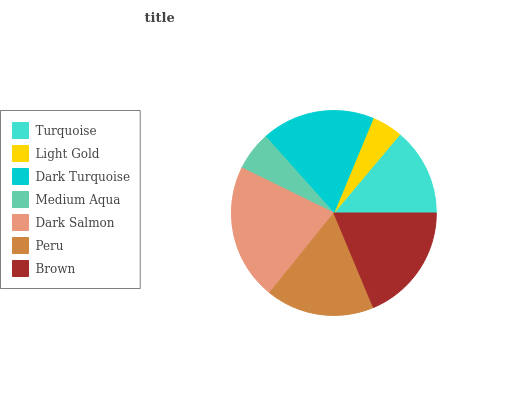Is Light Gold the minimum?
Answer yes or no. Yes. Is Dark Salmon the maximum?
Answer yes or no. Yes. Is Dark Turquoise the minimum?
Answer yes or no. No. Is Dark Turquoise the maximum?
Answer yes or no. No. Is Dark Turquoise greater than Light Gold?
Answer yes or no. Yes. Is Light Gold less than Dark Turquoise?
Answer yes or no. Yes. Is Light Gold greater than Dark Turquoise?
Answer yes or no. No. Is Dark Turquoise less than Light Gold?
Answer yes or no. No. Is Peru the high median?
Answer yes or no. Yes. Is Peru the low median?
Answer yes or no. Yes. Is Turquoise the high median?
Answer yes or no. No. Is Medium Aqua the low median?
Answer yes or no. No. 